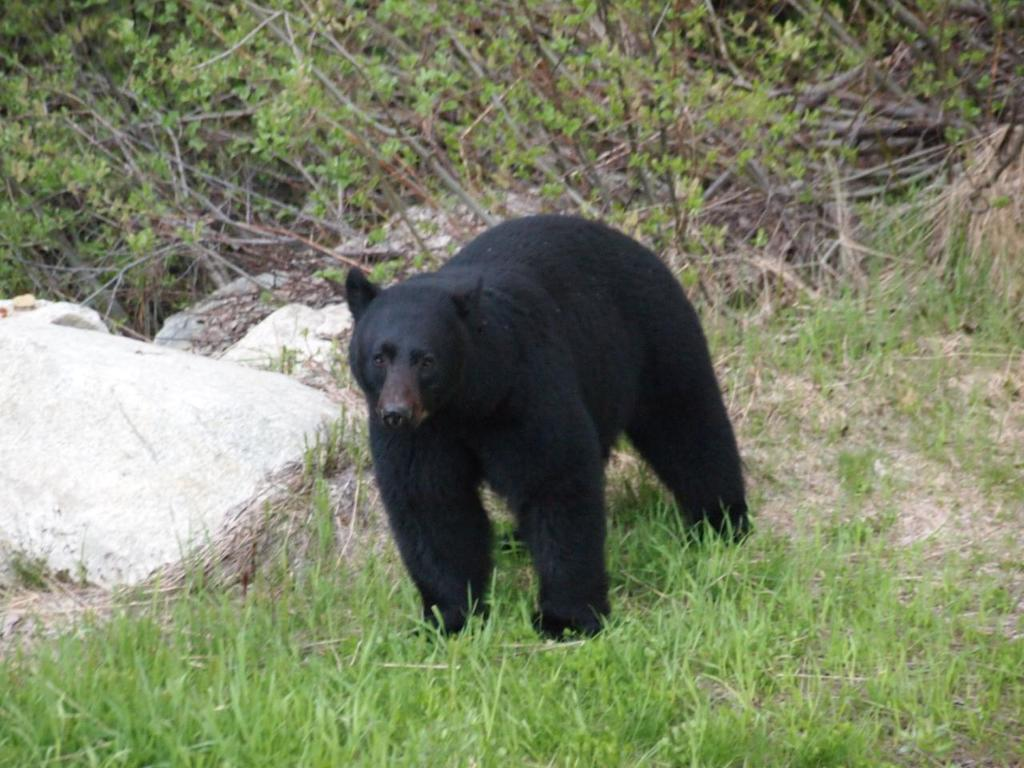What type of animal is in the image? There is a black bear in the image. What is the bear doing in the image? The bear is standing on the ground. What can be seen in the background of the image? There is grass, rocks, and plants in the background of the image. What type of clam is the bear holding in the image? There is no clam present in the image; the bear is standing on the ground without holding anything. 